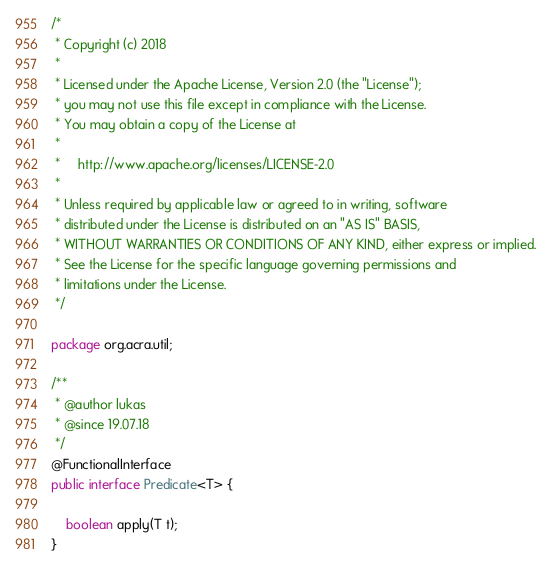Convert code to text. <code><loc_0><loc_0><loc_500><loc_500><_Java_>/*
 * Copyright (c) 2018
 *
 * Licensed under the Apache License, Version 2.0 (the "License");
 * you may not use this file except in compliance with the License.
 * You may obtain a copy of the License at
 *
 *     http://www.apache.org/licenses/LICENSE-2.0
 *
 * Unless required by applicable law or agreed to in writing, software
 * distributed under the License is distributed on an "AS IS" BASIS,
 * WITHOUT WARRANTIES OR CONDITIONS OF ANY KIND, either express or implied.
 * See the License for the specific language governing permissions and
 * limitations under the License.
 */

package org.acra.util;

/**
 * @author lukas
 * @since 19.07.18
 */
@FunctionalInterface
public interface Predicate<T> {

    boolean apply(T t);
}
</code> 